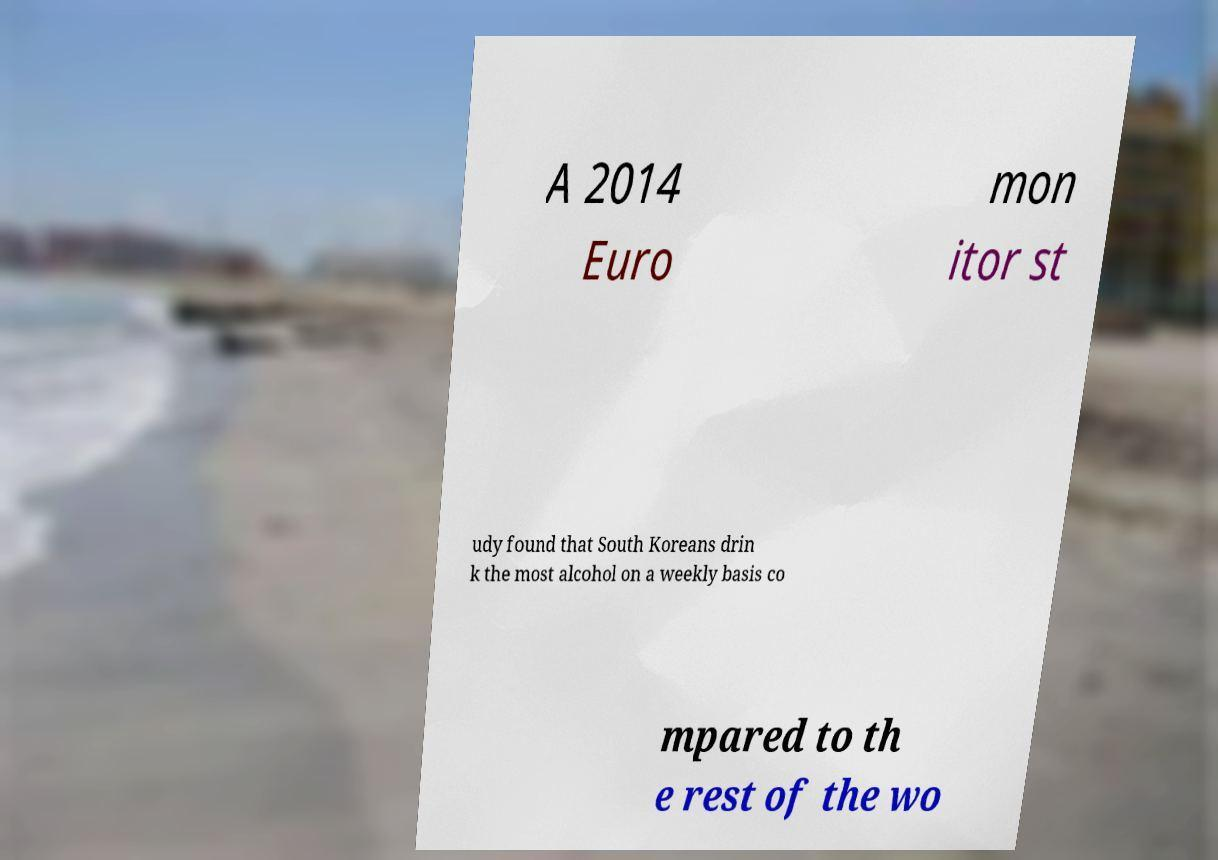Could you extract and type out the text from this image? A 2014 Euro mon itor st udy found that South Koreans drin k the most alcohol on a weekly basis co mpared to th e rest of the wo 